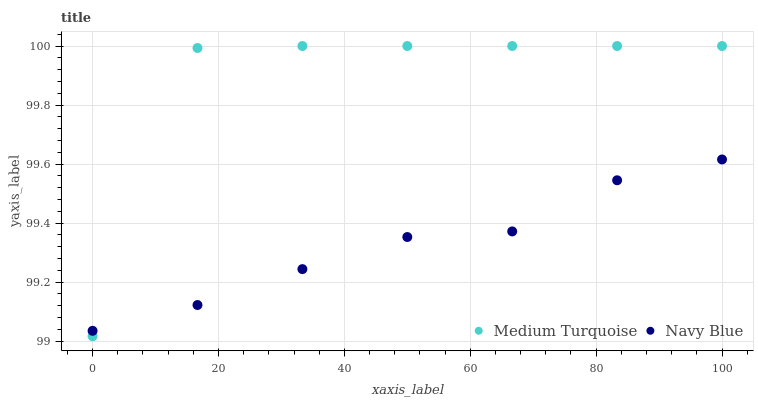Does Navy Blue have the minimum area under the curve?
Answer yes or no. Yes. Does Medium Turquoise have the maximum area under the curve?
Answer yes or no. Yes. Does Medium Turquoise have the minimum area under the curve?
Answer yes or no. No. Is Navy Blue the smoothest?
Answer yes or no. Yes. Is Medium Turquoise the roughest?
Answer yes or no. Yes. Is Medium Turquoise the smoothest?
Answer yes or no. No. Does Medium Turquoise have the lowest value?
Answer yes or no. Yes. Does Medium Turquoise have the highest value?
Answer yes or no. Yes. Does Navy Blue intersect Medium Turquoise?
Answer yes or no. Yes. Is Navy Blue less than Medium Turquoise?
Answer yes or no. No. Is Navy Blue greater than Medium Turquoise?
Answer yes or no. No. 